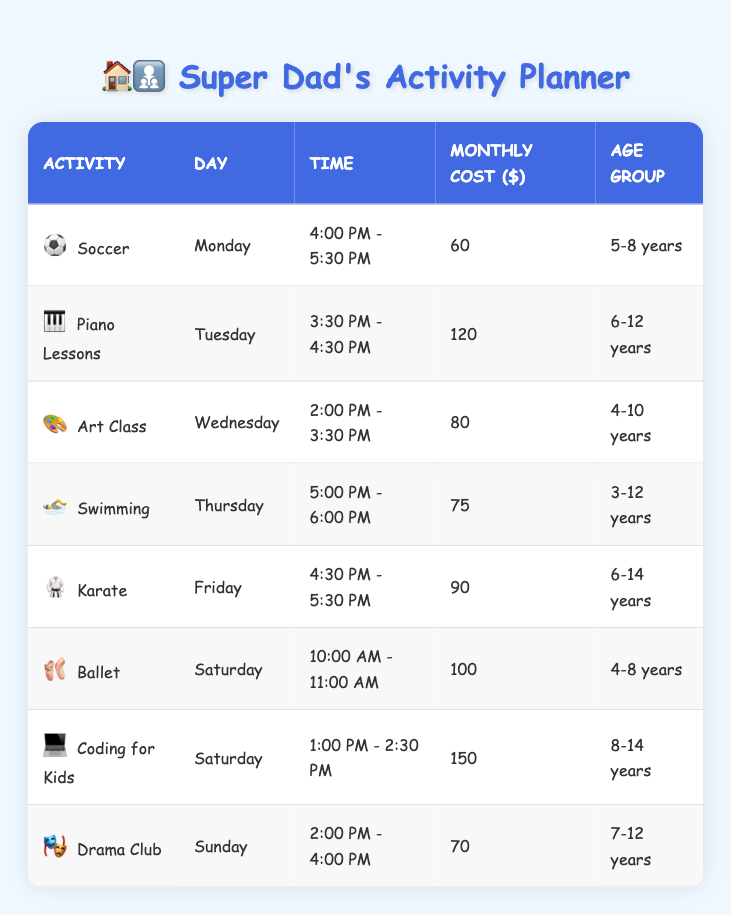What is the monthly cost of attending Piano Lessons? The table lists the monthly cost for each activity. For Piano Lessons, the cost is directly provided in the corresponding row as 120.
Answer: 120 Which activity is scheduled for Saturday? The table shows two activities on Saturday: Ballet from 10:00 AM - 11:00 AM and Coding for Kids from 1:00 PM - 2:30 PM.
Answer: Ballet and Coding for Kids Is the age group for Swimming 5-8 years? Checking the age group for Swimming from the table, it specifies 3-12 years, which does not include only 5-8 years. Therefore, this statement is false.
Answer: No What is the total monthly cost for activities on Saturday? From the table, the two activities on Saturday are Ballet with a cost of 100 and Coding for Kids with a cost of 150. Adding these gives 100 + 150 = 250.
Answer: 250 How many activities are available for children aged 6-12 years? The age group of 6-12 years applies to Piano Lessons and Drama Club, as seen in the table. Thus, there are two activities for this age group.
Answer: 2 What is the time for Art Class? The table lists the time for Art Class as 2:00 PM - 3:30 PM, which is a direct retrieval from the table.
Answer: 2:00 PM - 3:30 PM Are there any activities scheduled on Friday? Looking at the table, there is an activity on Friday, which is Karate from 4:30 PM - 5:30 PM. Thus, the answer is yes.
Answer: Yes Which activity is the most expensive, and how much does it cost? The coding directly from the table shows that Coding for Kids is listed with a monthly cost of 150, making it the most expensive activity.
Answer: Coding for Kids, 150 What is the average monthly cost of all activities listed in the table? To find the average, first sum all the monthly costs: 60 + 120 + 80 + 75 + 90 + 100 + 150 + 70 = 745. Next, divide by the number of activities (8) to get 745 / 8 = 93.125, which we can round to 93.
Answer: 93 